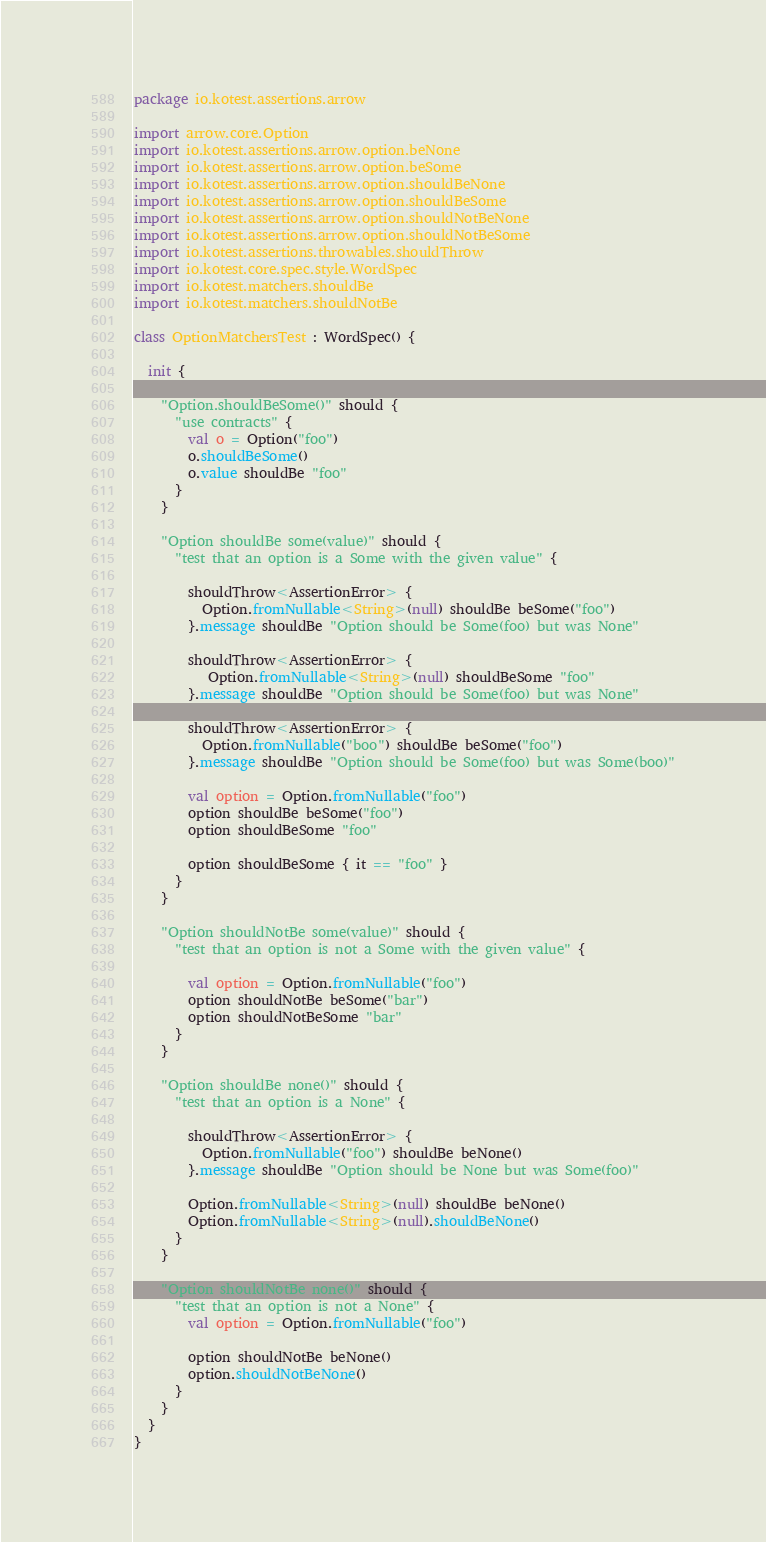<code> <loc_0><loc_0><loc_500><loc_500><_Kotlin_>package io.kotest.assertions.arrow

import arrow.core.Option
import io.kotest.assertions.arrow.option.beNone
import io.kotest.assertions.arrow.option.beSome
import io.kotest.assertions.arrow.option.shouldBeNone
import io.kotest.assertions.arrow.option.shouldBeSome
import io.kotest.assertions.arrow.option.shouldNotBeNone
import io.kotest.assertions.arrow.option.shouldNotBeSome
import io.kotest.assertions.throwables.shouldThrow
import io.kotest.core.spec.style.WordSpec
import io.kotest.matchers.shouldBe
import io.kotest.matchers.shouldNotBe

class OptionMatchersTest : WordSpec() {

  init {

    "Option.shouldBeSome()" should {
      "use contracts" {
        val o = Option("foo")
        o.shouldBeSome()
        o.value shouldBe "foo"
      }
    }

    "Option shouldBe some(value)" should {
      "test that an option is a Some with the given value" {

        shouldThrow<AssertionError> {
          Option.fromNullable<String>(null) shouldBe beSome("foo")
        }.message shouldBe "Option should be Some(foo) but was None"

        shouldThrow<AssertionError> {
           Option.fromNullable<String>(null) shouldBeSome "foo"
        }.message shouldBe "Option should be Some(foo) but was None"

        shouldThrow<AssertionError> {
          Option.fromNullable("boo") shouldBe beSome("foo")
        }.message shouldBe "Option should be Some(foo) but was Some(boo)"

        val option = Option.fromNullable("foo")
        option shouldBe beSome("foo")
        option shouldBeSome "foo"

        option shouldBeSome { it == "foo" }
      }
    }

    "Option shouldNotBe some(value)" should {
      "test that an option is not a Some with the given value" {

        val option = Option.fromNullable("foo")
        option shouldNotBe beSome("bar")
        option shouldNotBeSome "bar"
      }
    }

    "Option shouldBe none()" should {
      "test that an option is a None" {

        shouldThrow<AssertionError> {
          Option.fromNullable("foo") shouldBe beNone()
        }.message shouldBe "Option should be None but was Some(foo)"

        Option.fromNullable<String>(null) shouldBe beNone()
        Option.fromNullable<String>(null).shouldBeNone()
      }
    }

    "Option shouldNotBe none()" should {
      "test that an option is not a None" {
        val option = Option.fromNullable("foo")

        option shouldNotBe beNone()
        option.shouldNotBeNone()
      }
    }
  }
}
</code> 